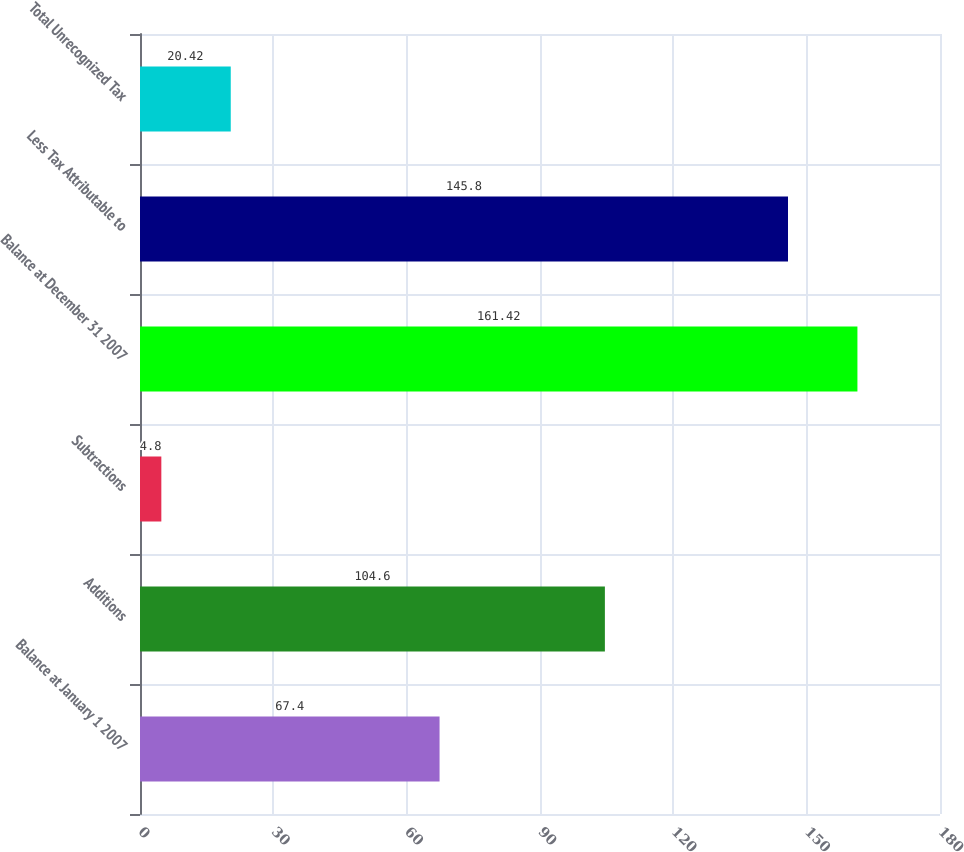Convert chart. <chart><loc_0><loc_0><loc_500><loc_500><bar_chart><fcel>Balance at January 1 2007<fcel>Additions<fcel>Subtractions<fcel>Balance at December 31 2007<fcel>Less Tax Attributable to<fcel>Total Unrecognized Tax<nl><fcel>67.4<fcel>104.6<fcel>4.8<fcel>161.42<fcel>145.8<fcel>20.42<nl></chart> 